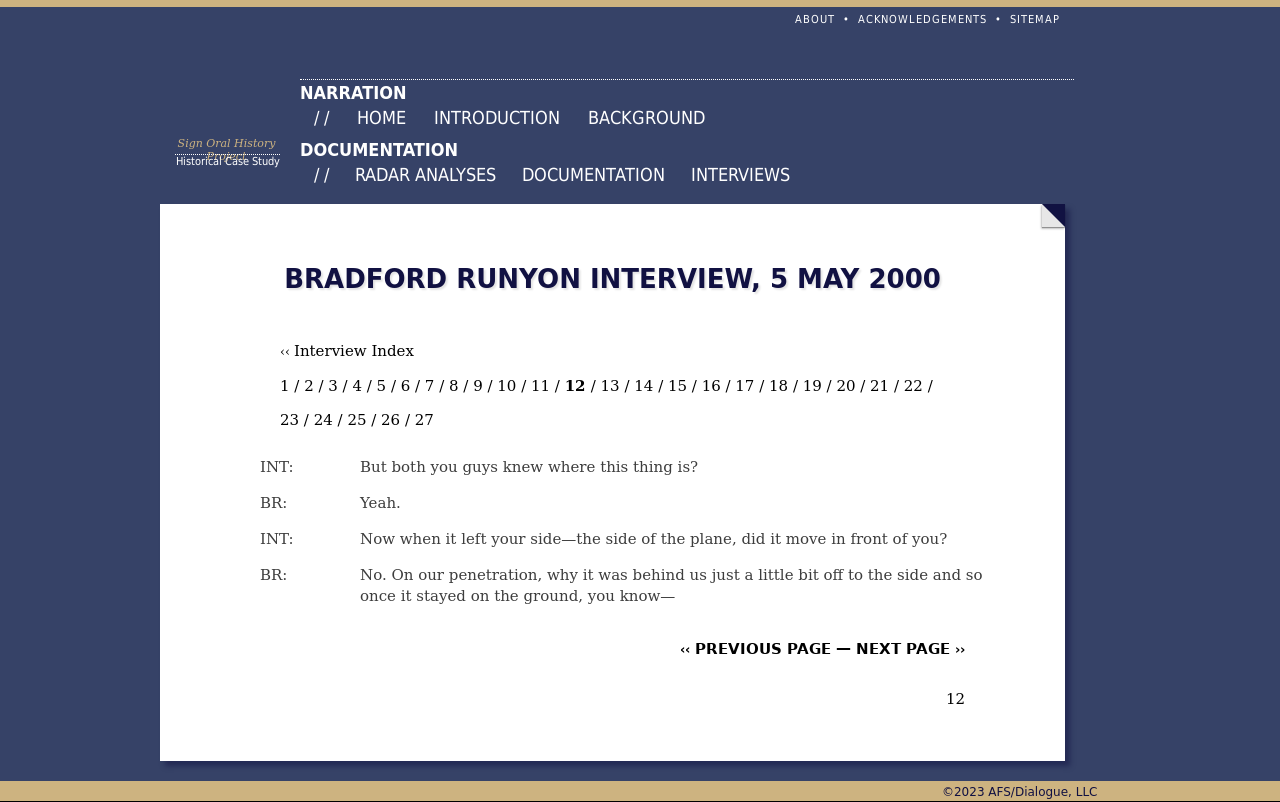What's the procedure for constructing this website from scratch with HTML? The image shows a digital document or web page, specifically displaying an interview. To construct a similar website using HTML from scratch, start by defining the structure with HTML to layout the main elements like headers, main content area, and footer. Use CSS for styling to achieve the aesthetic seen in the image, such as the background color, text fonts, and navigation bar styles. 